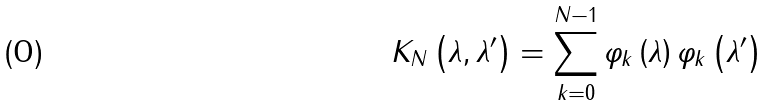<formula> <loc_0><loc_0><loc_500><loc_500>K _ { N } \left ( \lambda , \lambda ^ { \prime } \right ) = \sum _ { k = 0 } ^ { N - 1 } \varphi _ { k } \left ( \lambda \right ) \varphi _ { k } \left ( \lambda ^ { \prime } \right )</formula> 